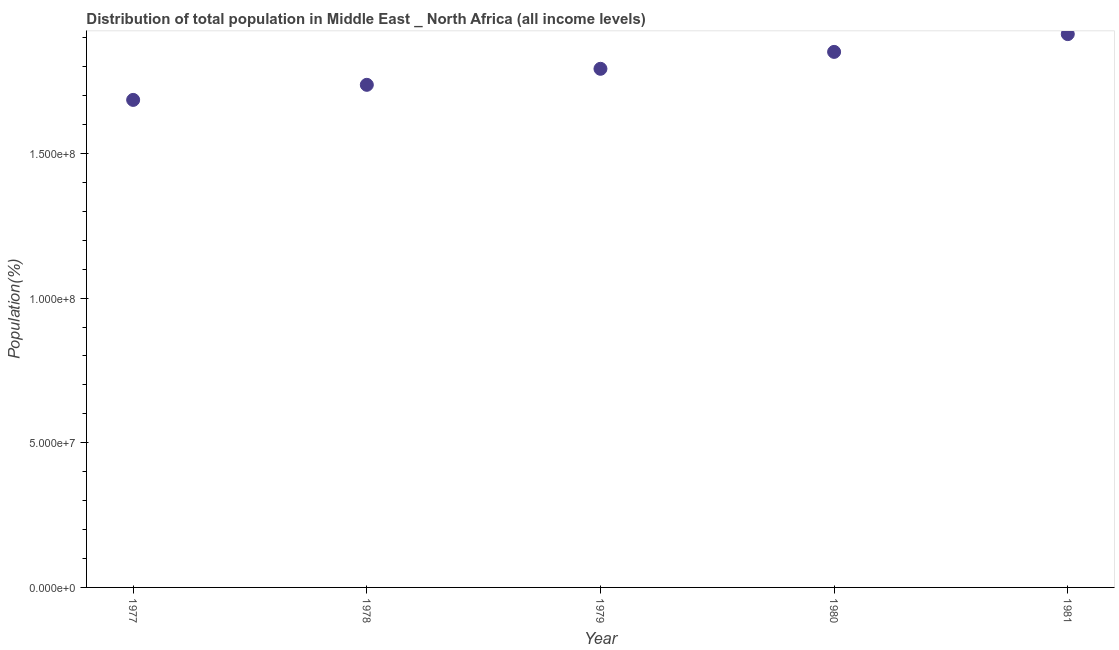What is the population in 1981?
Your answer should be compact. 1.91e+08. Across all years, what is the maximum population?
Keep it short and to the point. 1.91e+08. Across all years, what is the minimum population?
Offer a very short reply. 1.68e+08. What is the sum of the population?
Offer a terse response. 8.98e+08. What is the difference between the population in 1980 and 1981?
Offer a very short reply. -6.14e+06. What is the average population per year?
Your response must be concise. 1.80e+08. What is the median population?
Make the answer very short. 1.79e+08. What is the ratio of the population in 1977 to that in 1978?
Your answer should be very brief. 0.97. Is the population in 1980 less than that in 1981?
Make the answer very short. Yes. Is the difference between the population in 1979 and 1980 greater than the difference between any two years?
Your answer should be very brief. No. What is the difference between the highest and the second highest population?
Provide a succinct answer. 6.14e+06. Is the sum of the population in 1978 and 1980 greater than the maximum population across all years?
Give a very brief answer. Yes. What is the difference between the highest and the lowest population?
Make the answer very short. 2.27e+07. What is the difference between two consecutive major ticks on the Y-axis?
Offer a terse response. 5.00e+07. Are the values on the major ticks of Y-axis written in scientific E-notation?
Your response must be concise. Yes. Does the graph contain any zero values?
Your response must be concise. No. Does the graph contain grids?
Offer a terse response. No. What is the title of the graph?
Keep it short and to the point. Distribution of total population in Middle East _ North Africa (all income levels) . What is the label or title of the Y-axis?
Your answer should be compact. Population(%). What is the Population(%) in 1977?
Give a very brief answer. 1.68e+08. What is the Population(%) in 1978?
Provide a succinct answer. 1.74e+08. What is the Population(%) in 1979?
Your response must be concise. 1.79e+08. What is the Population(%) in 1980?
Your response must be concise. 1.85e+08. What is the Population(%) in 1981?
Make the answer very short. 1.91e+08. What is the difference between the Population(%) in 1977 and 1978?
Provide a succinct answer. -5.21e+06. What is the difference between the Population(%) in 1977 and 1979?
Keep it short and to the point. -1.07e+07. What is the difference between the Population(%) in 1977 and 1980?
Your response must be concise. -1.66e+07. What is the difference between the Population(%) in 1977 and 1981?
Your response must be concise. -2.27e+07. What is the difference between the Population(%) in 1978 and 1979?
Make the answer very short. -5.54e+06. What is the difference between the Population(%) in 1978 and 1980?
Provide a short and direct response. -1.14e+07. What is the difference between the Population(%) in 1978 and 1981?
Give a very brief answer. -1.75e+07. What is the difference between the Population(%) in 1979 and 1980?
Offer a terse response. -5.85e+06. What is the difference between the Population(%) in 1979 and 1981?
Ensure brevity in your answer.  -1.20e+07. What is the difference between the Population(%) in 1980 and 1981?
Your response must be concise. -6.14e+06. What is the ratio of the Population(%) in 1977 to that in 1978?
Keep it short and to the point. 0.97. What is the ratio of the Population(%) in 1977 to that in 1979?
Provide a short and direct response. 0.94. What is the ratio of the Population(%) in 1977 to that in 1980?
Offer a very short reply. 0.91. What is the ratio of the Population(%) in 1977 to that in 1981?
Your answer should be very brief. 0.88. What is the ratio of the Population(%) in 1978 to that in 1980?
Keep it short and to the point. 0.94. What is the ratio of the Population(%) in 1978 to that in 1981?
Offer a terse response. 0.91. What is the ratio of the Population(%) in 1979 to that in 1981?
Provide a short and direct response. 0.94. 